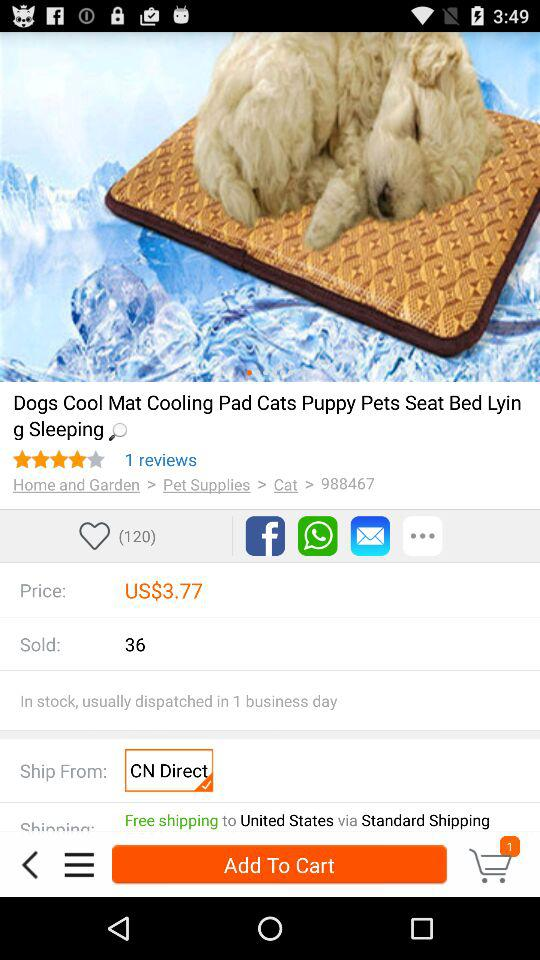What is the price of the Dogs Cool mat? The price is "$3.77". 